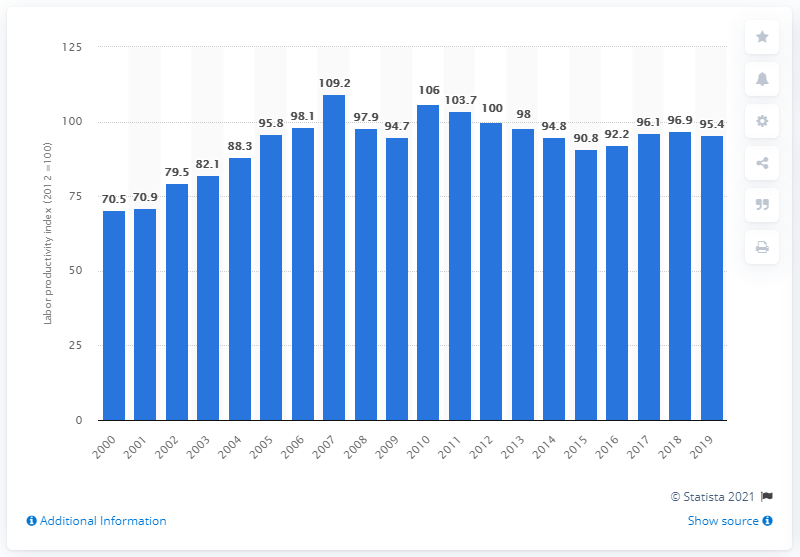Indicate a few pertinent items in this graphic. According to the labor productivity index in 2019, the productivity level was 95.4%. 